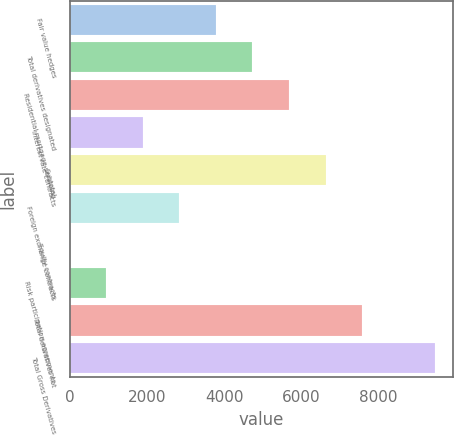Convert chart. <chart><loc_0><loc_0><loc_500><loc_500><bar_chart><fcel>Fair value hedges<fcel>Total derivatives designated<fcel>Residential mortgage servicing<fcel>Interest rate contracts<fcel>Subtotal<fcel>Foreign exchange contracts<fcel>Equity contracts<fcel>Risk participation agreements<fcel>Total derivatives not<fcel>Total Gross Derivatives<nl><fcel>3788.2<fcel>4734<fcel>5679.8<fcel>1896.6<fcel>6625.6<fcel>2842.4<fcel>5<fcel>950.8<fcel>7575<fcel>9463<nl></chart> 